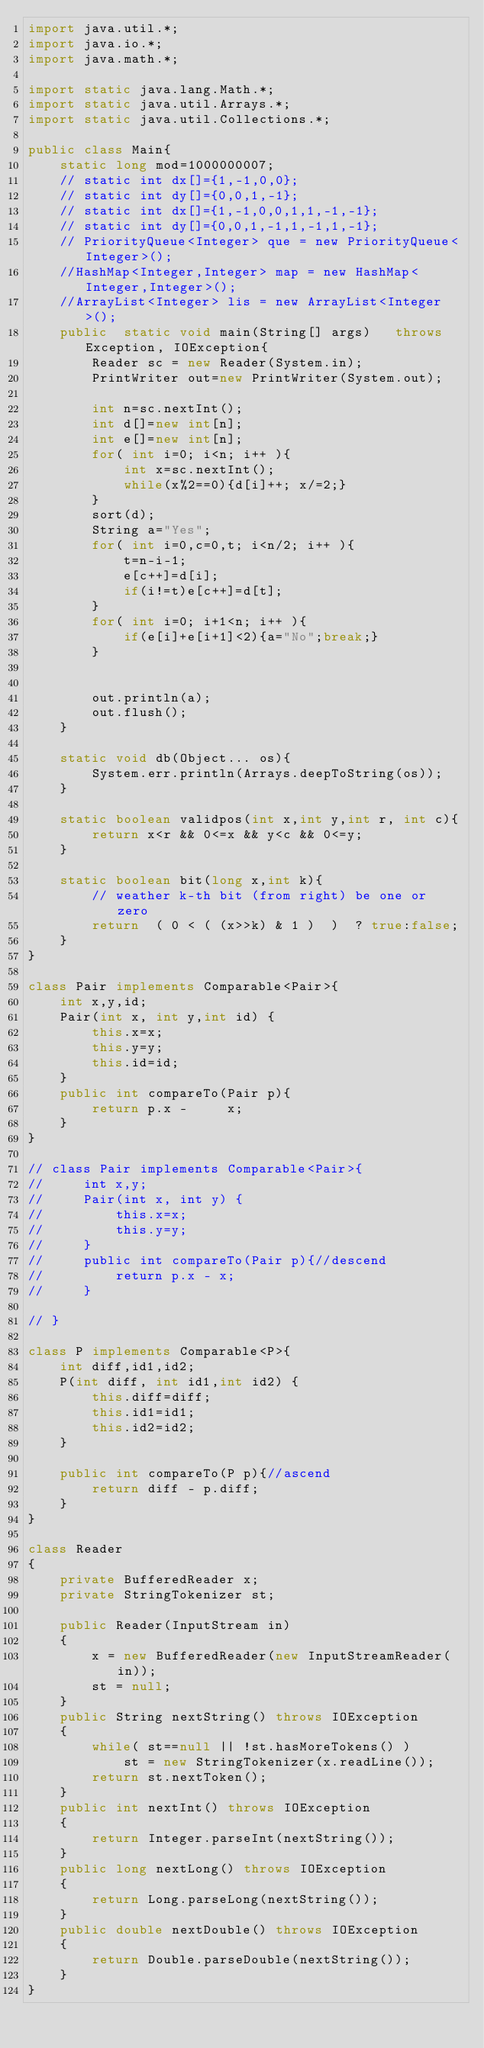Convert code to text. <code><loc_0><loc_0><loc_500><loc_500><_Java_>import java.util.*;
import java.io.*;
import java.math.*;

import static java.lang.Math.*;
import static java.util.Arrays.*;
import static java.util.Collections.*;

public class Main{
    static long mod=1000000007;
    // static int dx[]={1,-1,0,0};
    // static int dy[]={0,0,1,-1};
    // static int dx[]={1,-1,0,0,1,1,-1,-1};
    // static int dy[]={0,0,1,-1,1,-1,1,-1};
    // PriorityQueue<Integer> que = new PriorityQueue<Integer>(); 
    //HashMap<Integer,Integer> map = new HashMap<Integer,Integer>();
    //ArrayList<Integer> lis = new ArrayList<Integer>();
    public  static void main(String[] args)   throws Exception, IOException{
        Reader sc = new Reader(System.in);
        PrintWriter out=new PrintWriter(System.out);

        int n=sc.nextInt();
        int d[]=new int[n];
        int e[]=new int[n];
        for( int i=0; i<n; i++ ){
            int x=sc.nextInt();
            while(x%2==0){d[i]++; x/=2;}
        }
        sort(d);
        String a="Yes";
        for( int i=0,c=0,t; i<n/2; i++ ){
            t=n-i-1;
            e[c++]=d[i];
            if(i!=t)e[c++]=d[t];
        }
        for( int i=0; i+1<n; i++ ){
            if(e[i]+e[i+1]<2){a="No";break;}
        }    

       
        out.println(a); 
        out.flush();
    }

    static void db(Object... os){
        System.err.println(Arrays.deepToString(os));
    }

    static boolean validpos(int x,int y,int r, int c){
        return x<r && 0<=x && y<c && 0<=y;
    }
     
    static boolean bit(long x,int k){
        // weather k-th bit (from right) be one or zero
        return  ( 0 < ( (x>>k) & 1 )  )  ? true:false;
    }
}

class Pair implements Comparable<Pair>{
    int x,y,id;
    Pair(int x, int y,int id) {
        this.x=x;
        this.y=y;
        this.id=id;
    } 
    public int compareTo(Pair p){
        return p.x -     x;
    } 
}

// class Pair implements Comparable<Pair>{
//     int x,y;
//     Pair(int x, int y) {
//         this.x=x;
//         this.y=y;
//     } 
//     public int compareTo(Pair p){//descend
//         return p.x - x;
//     } 

// }

class P implements Comparable<P>{
    int diff,id1,id2;
    P(int diff, int id1,int id2) {
        this.diff=diff;
        this.id1=id1;
        this.id2=id2;
    } 
      
    public int compareTo(P p){//ascend
        return diff - p.diff;
    } 
}

class Reader
{ 
    private BufferedReader x;
    private StringTokenizer st;
    
    public Reader(InputStream in)
    {
        x = new BufferedReader(new InputStreamReader(in));
        st = null;
    }
    public String nextString() throws IOException
    {
        while( st==null || !st.hasMoreTokens() )
            st = new StringTokenizer(x.readLine());
        return st.nextToken();
    }
    public int nextInt() throws IOException
    {
        return Integer.parseInt(nextString());
    }
    public long nextLong() throws IOException
    {
        return Long.parseLong(nextString());
    }
    public double nextDouble() throws IOException
    {
        return Double.parseDouble(nextString());
    }
}</code> 